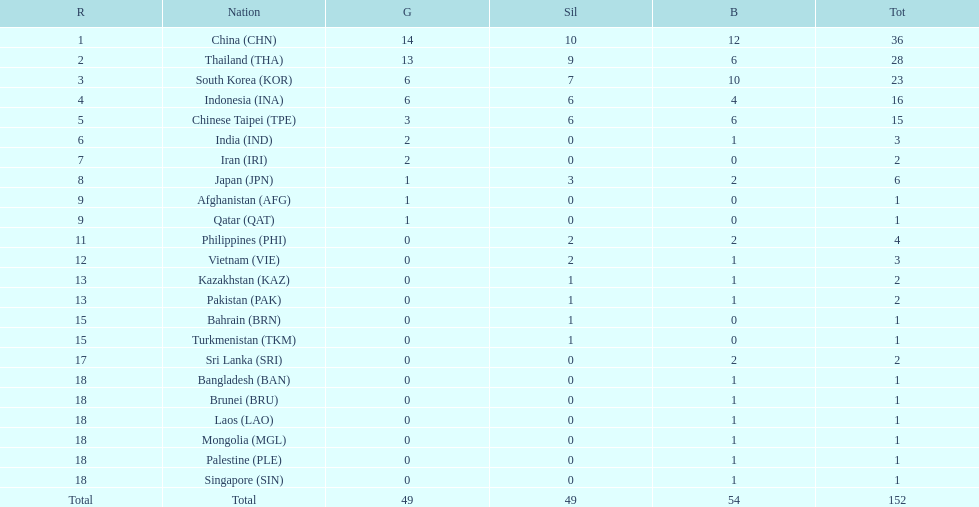How many nations won no silver medals at all? 11. 